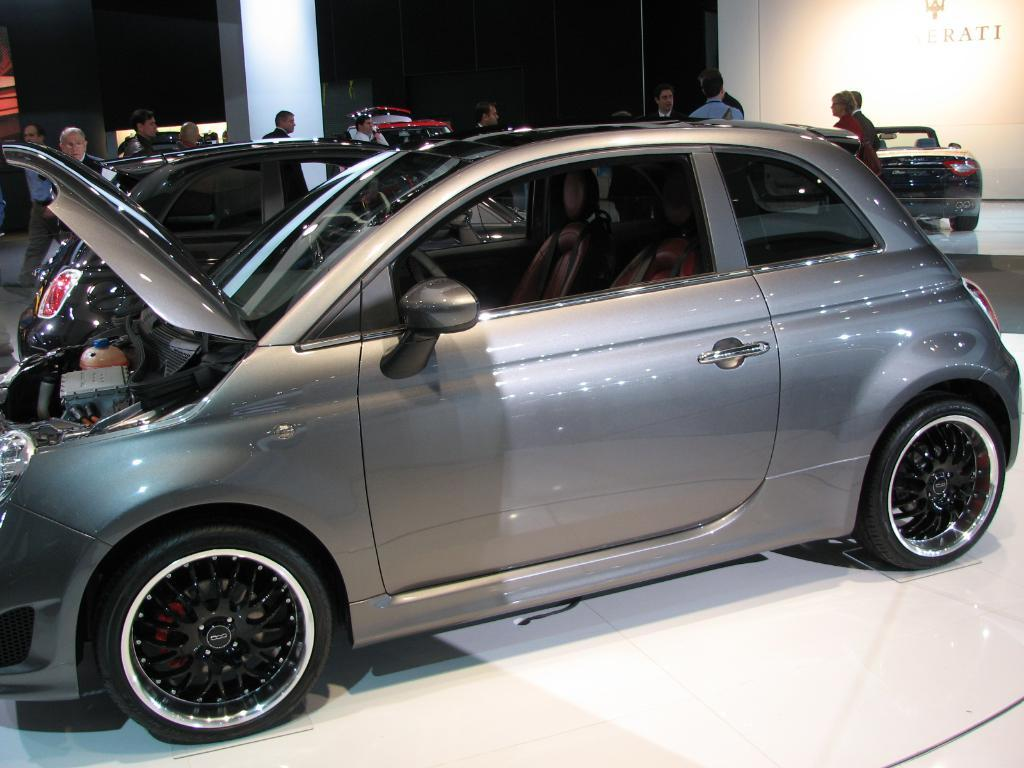What type of objects can be seen in the image? There are motor vehicles in the image. Can you describe the people in the image? There are persons on the floor in the image. How many chairs can be seen in the image? There are no chairs present in the image. What type of parcel is being delivered by the motor vehicles in the image? There is no parcel visible in the image, and the purpose of the motor vehicles is not mentioned. Is there any lettuce growing in the image? There is no lettuce present in the image. 